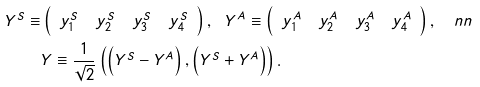<formula> <loc_0><loc_0><loc_500><loc_500>Y ^ { S } \equiv & \left ( \begin{array} { c c c c } y ^ { S } _ { 1 } & y ^ { S } _ { 2 } & y ^ { S } _ { 3 } & y ^ { S } _ { 4 } \end{array} \right ) , \ \ Y ^ { A } \equiv \left ( \begin{array} { c c c c } y ^ { A } _ { 1 } & y ^ { A } _ { 2 } & y ^ { A } _ { 3 } & y ^ { A } _ { 4 } \end{array} \right ) , \quad n n \\ & Y \equiv \frac { 1 } { \sqrt { 2 } } \left ( \left ( Y ^ { S } - Y ^ { A } \right ) , \left ( Y ^ { S } + Y ^ { A } \right ) \right ) .</formula> 